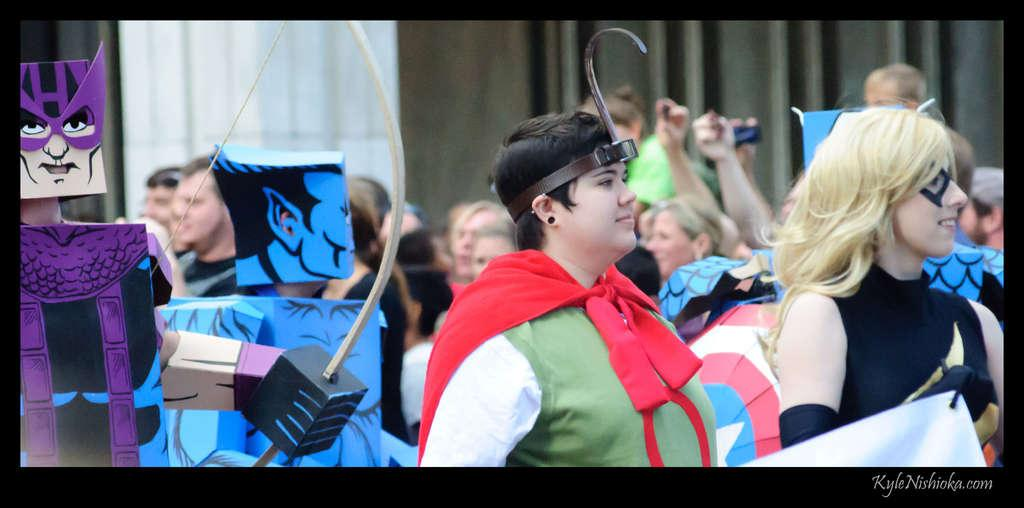What type of costumes are the people wearing in the image? The people in the image are wearing cosplay costumes. Where are the people in cosplay costumes positioned in the image? The people in cosplay costumes are standing in the front. Are there any other people visible in the image? Yes, there are people visible behind the people in cosplay costumes. What can be seen in the background of the image? There is a wall in the background of the image. What type of blade is being used to cover the people in the image? There is no blade present in the image, and the people are not being covered. 